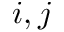Convert formula to latex. <formula><loc_0><loc_0><loc_500><loc_500>i , j</formula> 